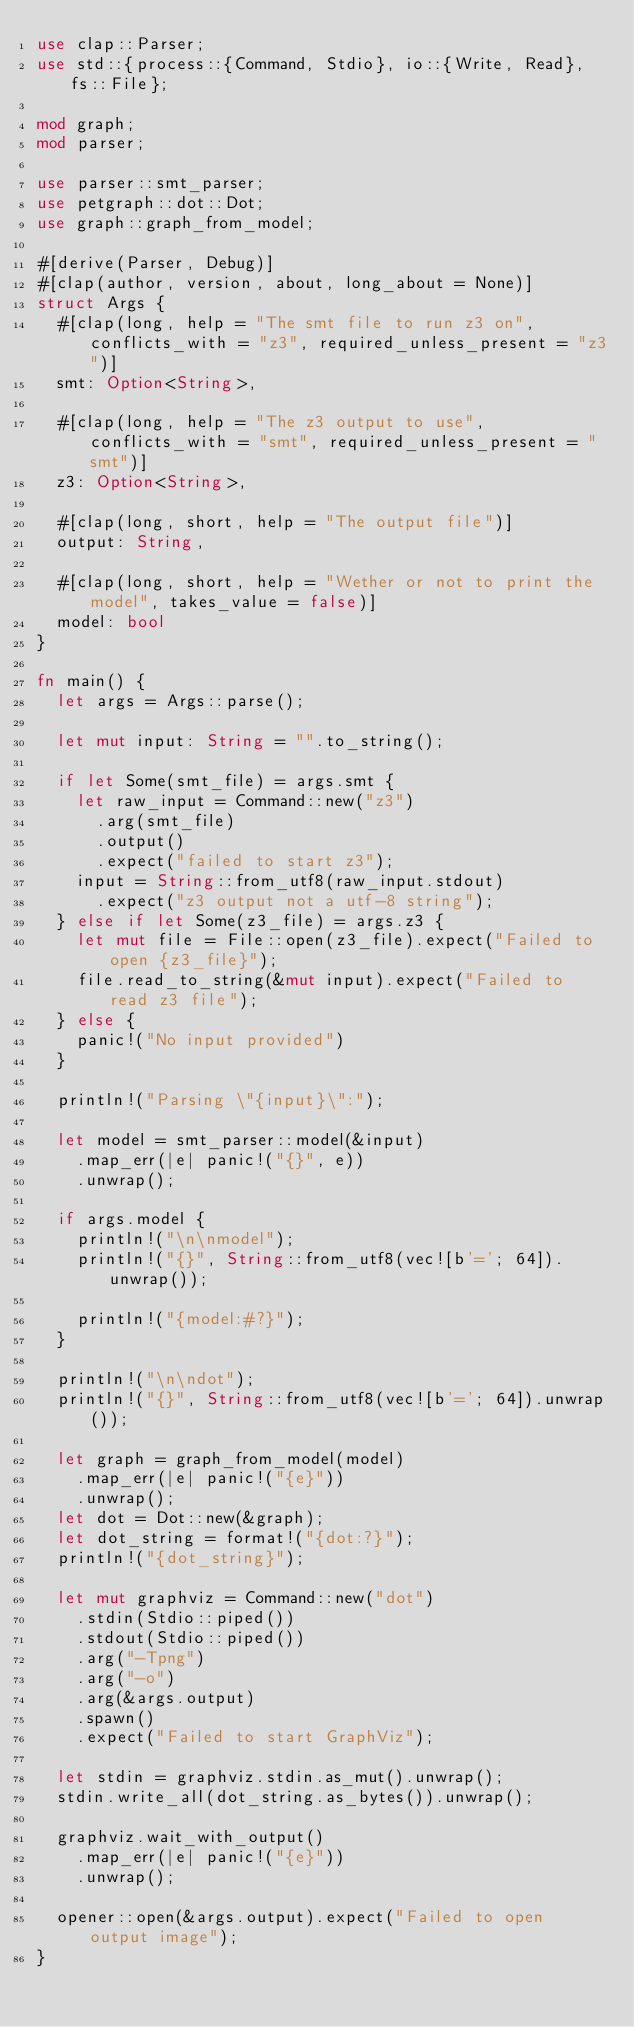Convert code to text. <code><loc_0><loc_0><loc_500><loc_500><_Rust_>use clap::Parser;
use std::{process::{Command, Stdio}, io::{Write, Read}, fs::File};

mod graph;
mod parser;

use parser::smt_parser;
use petgraph::dot::Dot;
use graph::graph_from_model;

#[derive(Parser, Debug)]
#[clap(author, version, about, long_about = None)]
struct Args {
  #[clap(long, help = "The smt file to run z3 on", conflicts_with = "z3", required_unless_present = "z3")]
  smt: Option<String>,

  #[clap(long, help = "The z3 output to use", conflicts_with = "smt", required_unless_present = "smt")]
  z3: Option<String>,

  #[clap(long, short, help = "The output file")]
  output: String,

  #[clap(long, short, help = "Wether or not to print the model", takes_value = false)]
  model: bool
}

fn main() {
  let args = Args::parse();

  let mut input: String = "".to_string();

  if let Some(smt_file) = args.smt {
    let raw_input = Command::new("z3")
      .arg(smt_file)
      .output()
      .expect("failed to start z3");
    input = String::from_utf8(raw_input.stdout)
      .expect("z3 output not a utf-8 string");
  } else if let Some(z3_file) = args.z3 {
    let mut file = File::open(z3_file).expect("Failed to open {z3_file}");
    file.read_to_string(&mut input).expect("Failed to read z3 file");
  } else {
    panic!("No input provided")
  }

  println!("Parsing \"{input}\":");
  
  let model = smt_parser::model(&input)
    .map_err(|e| panic!("{}", e))
    .unwrap();

  if args.model {
    println!("\n\nmodel");
    println!("{}", String::from_utf8(vec![b'='; 64]).unwrap());
    
    println!("{model:#?}");
  }

  println!("\n\ndot");
  println!("{}", String::from_utf8(vec![b'='; 64]).unwrap());
  
  let graph = graph_from_model(model)
    .map_err(|e| panic!("{e}"))
    .unwrap();
  let dot = Dot::new(&graph);
  let dot_string = format!("{dot:?}");
  println!("{dot_string}");

  let mut graphviz = Command::new("dot")
    .stdin(Stdio::piped())
    .stdout(Stdio::piped())
    .arg("-Tpng")
    .arg("-o")
    .arg(&args.output)
    .spawn()
    .expect("Failed to start GraphViz");

  let stdin = graphviz.stdin.as_mut().unwrap();
  stdin.write_all(dot_string.as_bytes()).unwrap();

  graphviz.wait_with_output()
    .map_err(|e| panic!("{e}"))
    .unwrap();
  
  opener::open(&args.output).expect("Failed to open output image");
}
</code> 